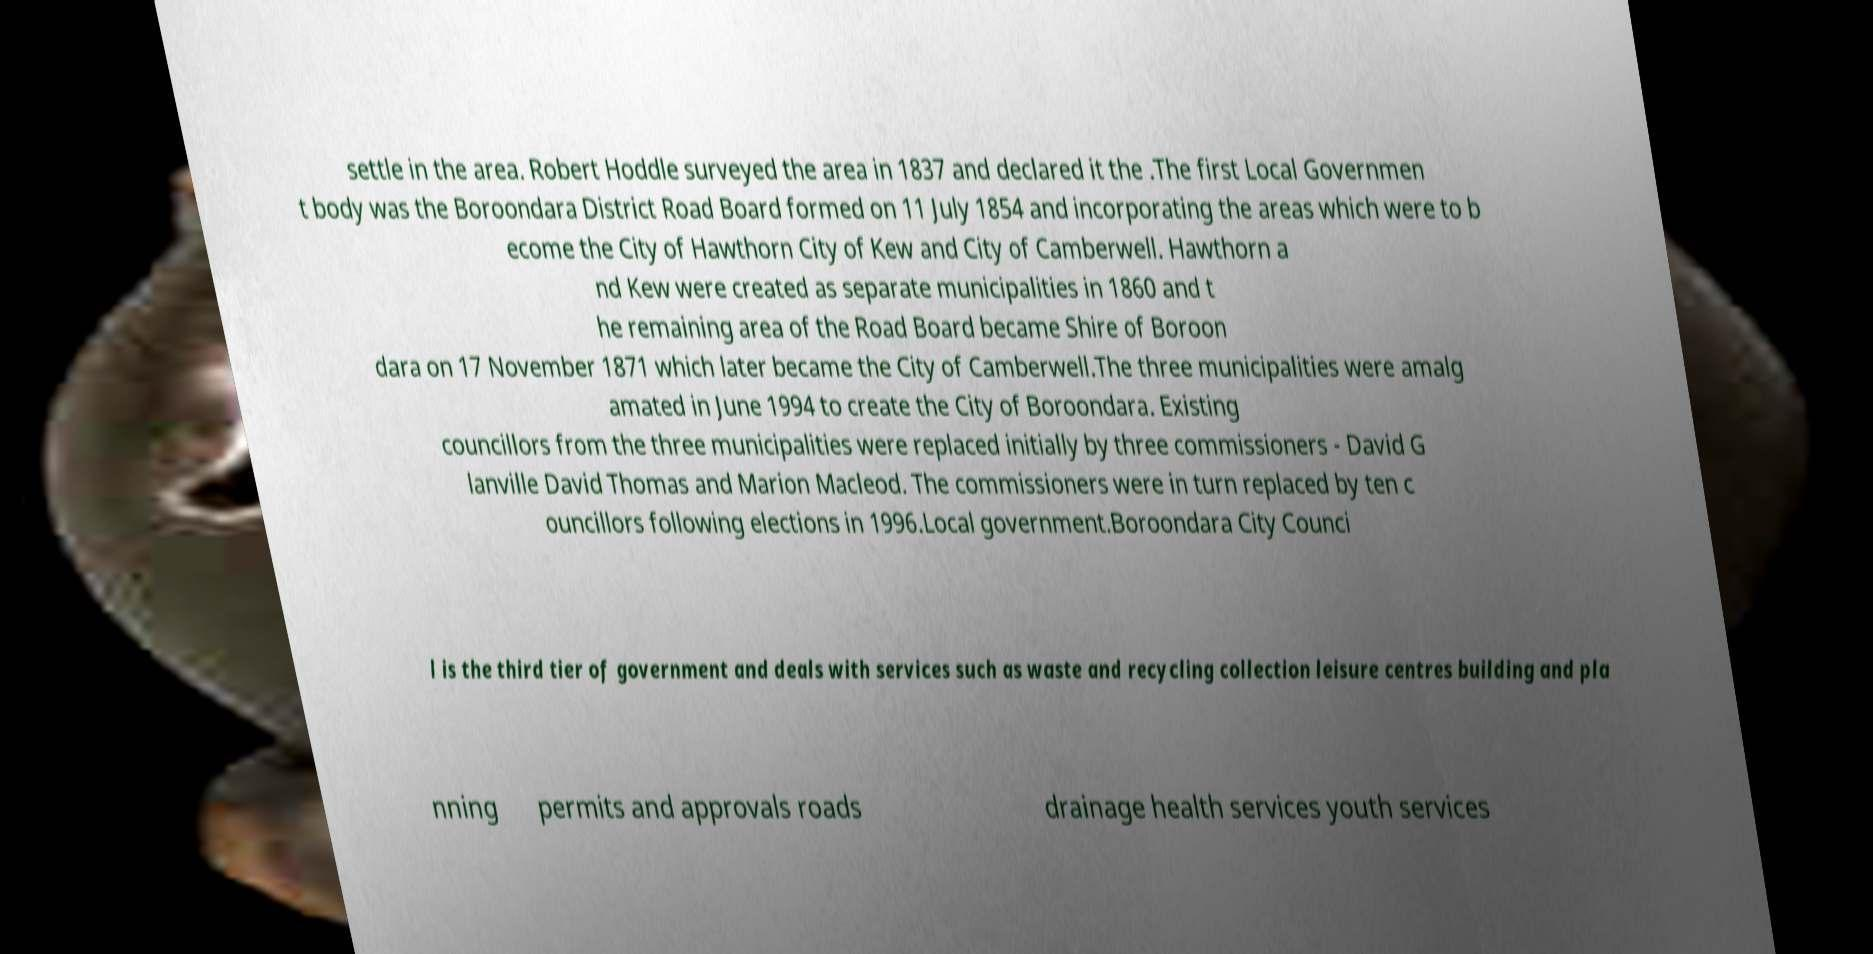Please read and relay the text visible in this image. What does it say? settle in the area. Robert Hoddle surveyed the area in 1837 and declared it the .The first Local Governmen t body was the Boroondara District Road Board formed on 11 July 1854 and incorporating the areas which were to b ecome the City of Hawthorn City of Kew and City of Camberwell. Hawthorn a nd Kew were created as separate municipalities in 1860 and t he remaining area of the Road Board became Shire of Boroon dara on 17 November 1871 which later became the City of Camberwell.The three municipalities were amalg amated in June 1994 to create the City of Boroondara. Existing councillors from the three municipalities were replaced initially by three commissioners - David G lanville David Thomas and Marion Macleod. The commissioners were in turn replaced by ten c ouncillors following elections in 1996.Local government.Boroondara City Counci l is the third tier of government and deals with services such as waste and recycling collection leisure centres building and pla nning permits and approvals roads drainage health services youth services 